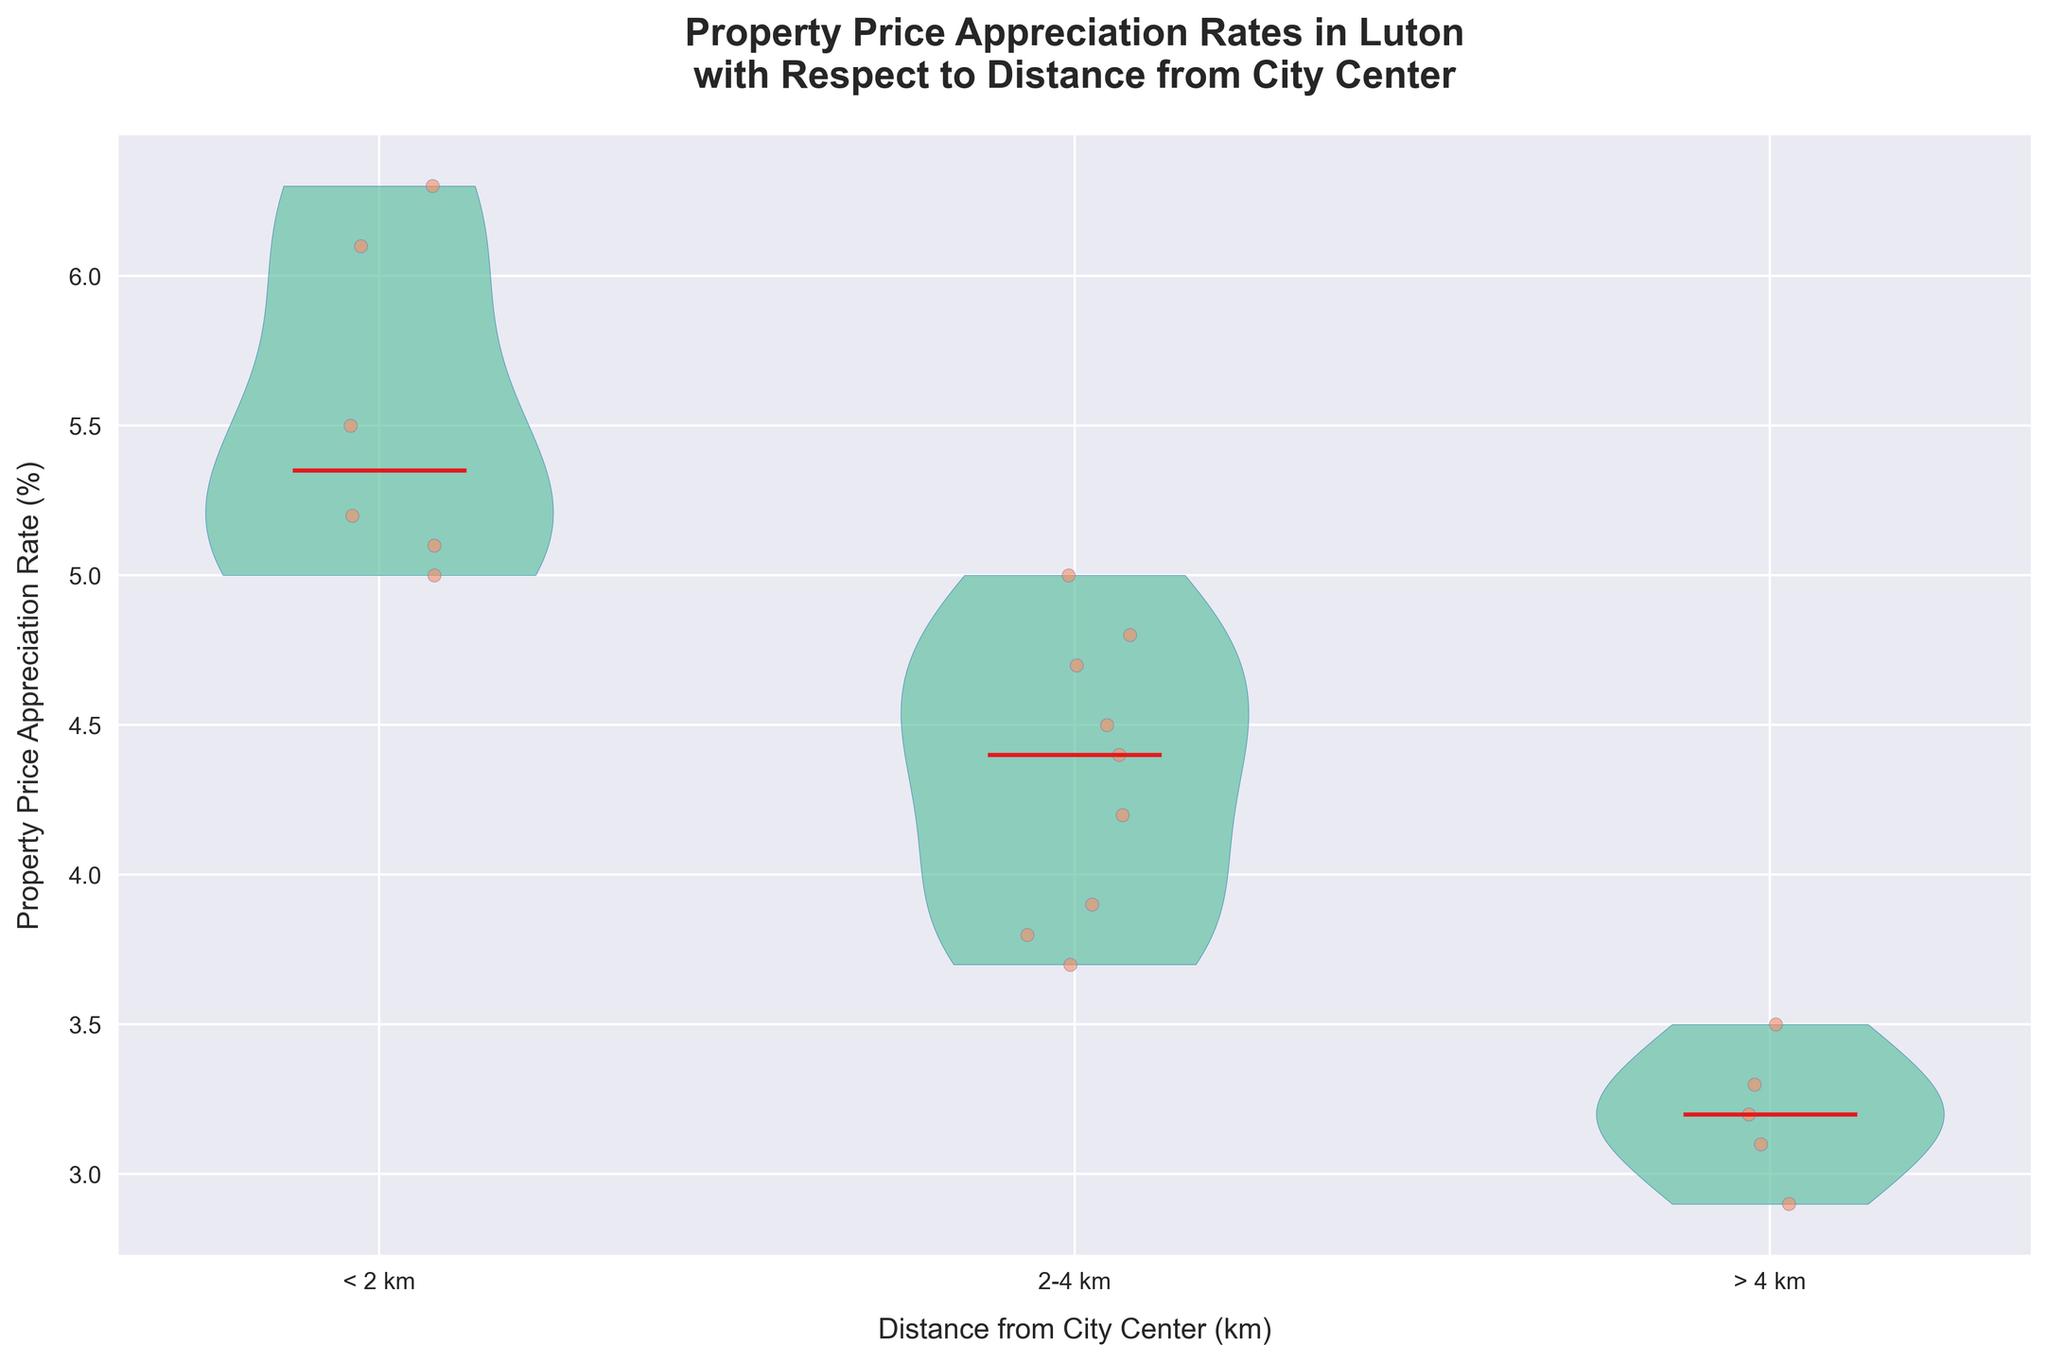What's the title of the figure? The title is displayed at the top of the figure. It reads "Property Price Appreciation Rates in Luton with Respect to Distance from City Center".
Answer: Property Price Appreciation Rates in Luton with Respect to Distance from City Center What do the colors of the jittered points represent? The jittered points are uniformly colored; hence, color doesn't represent any specific category. The jittered point color '#fc8d62' is used for visual differentiation and aesthetic consistency.
Answer: Visual differentiation How is the median value represented in the violin plots? The median value in the violin plots is represented by a red line. This visual cue is consistent across all groups shown in the violin plots.
Answer: Red line Which distance group shows the highest median property price appreciation rate? By examining the red median lines, we see that the group '< 2 km' has the highest median property price appreciation rate compared to the groups '2-4 km' and '> 4 km'.
Answer: < 2 km What's the median property price appreciation rate for properties located more than 4 km from the city center? Observe the red median line within the rightmost violin plot, which represents properties located more than 4 km from the city center. This line is at approximately 3.2%.
Answer: 3.2% What is the overall trend of property price appreciation rates as the distance from the city center increases? By analyzing the median lines: the property price appreciation rates tend to decrease as the distance from the city center increases. The highest rates are closer to the city center, and the rates diminish further away.
Answer: Decrease Which distance range shows the widest distribution of property price appreciation rates? To find the widest distribution, observe the span of the violin plot's width at different points. The '< 2 km' group's violin plot shows a wider distribution than the others.
Answer: < 2 km Compare the median appreciation rates of '< 2 km' and '2-4 km'. Which is higher and by how much? '< 2 km' has a median around 5.3%, while '2-4 km' has a median around 4.5%. The difference is 5.3% - 4.5% = 0.8%.
Answer: < 2 km by 0.8% How many distinct distance groups are presented in the violin plots? There are three distinct distance groups represented by three separate violin plots. These groups are '< 2 km', '2-4 km', and '> 4 km'.
Answer: Three What is the approximate range of property price appreciation rates for properties located 2-4 km from the city center? Observe the span of the violin plot representing the '2-4 km' group. The range of property price appreciation rates is from approximately 3.2% to 5.0%.
Answer: 3.2% to 5.0% 